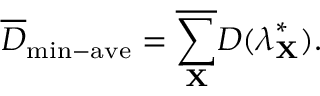Convert formula to latex. <formula><loc_0><loc_0><loc_500><loc_500>\overline { D } _ { \min - a v e } = \overline { { \sum _ { X } } } D ( \lambda _ { X } ^ { * } ) .</formula> 